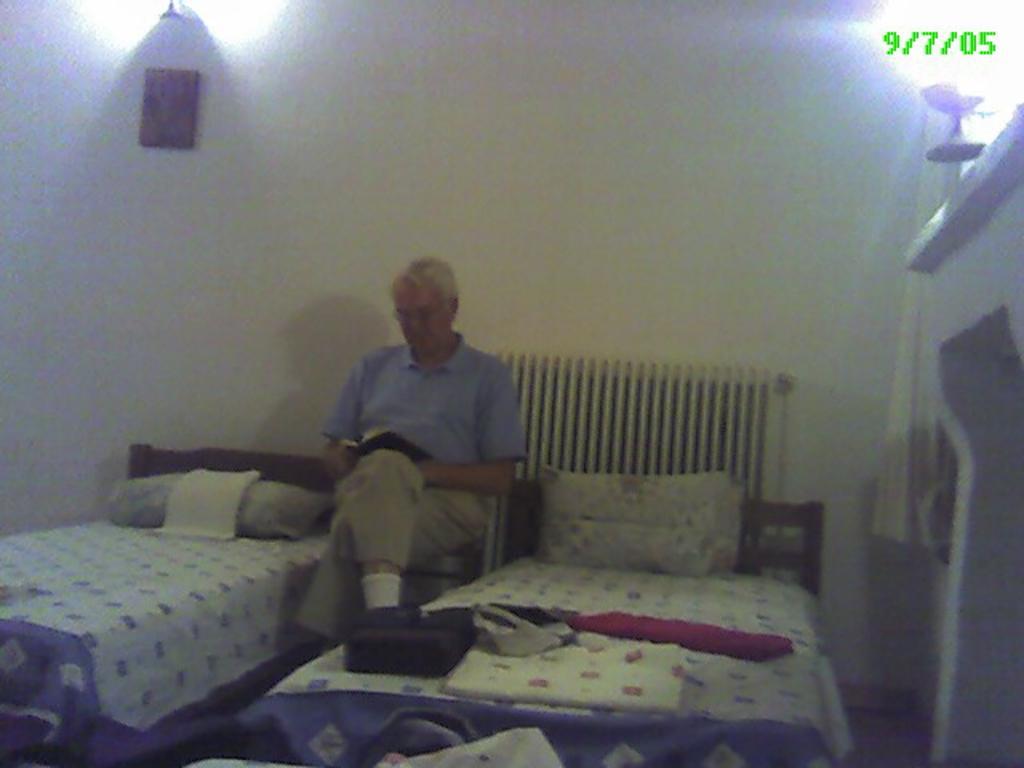Describe this image in one or two sentences. In this picture we can see a wall at the back, and a person sitting on a chair and reading a novel ,and here is the bed with a pillow on it, and at left side here is a cot ,and at above here is the lamp. 